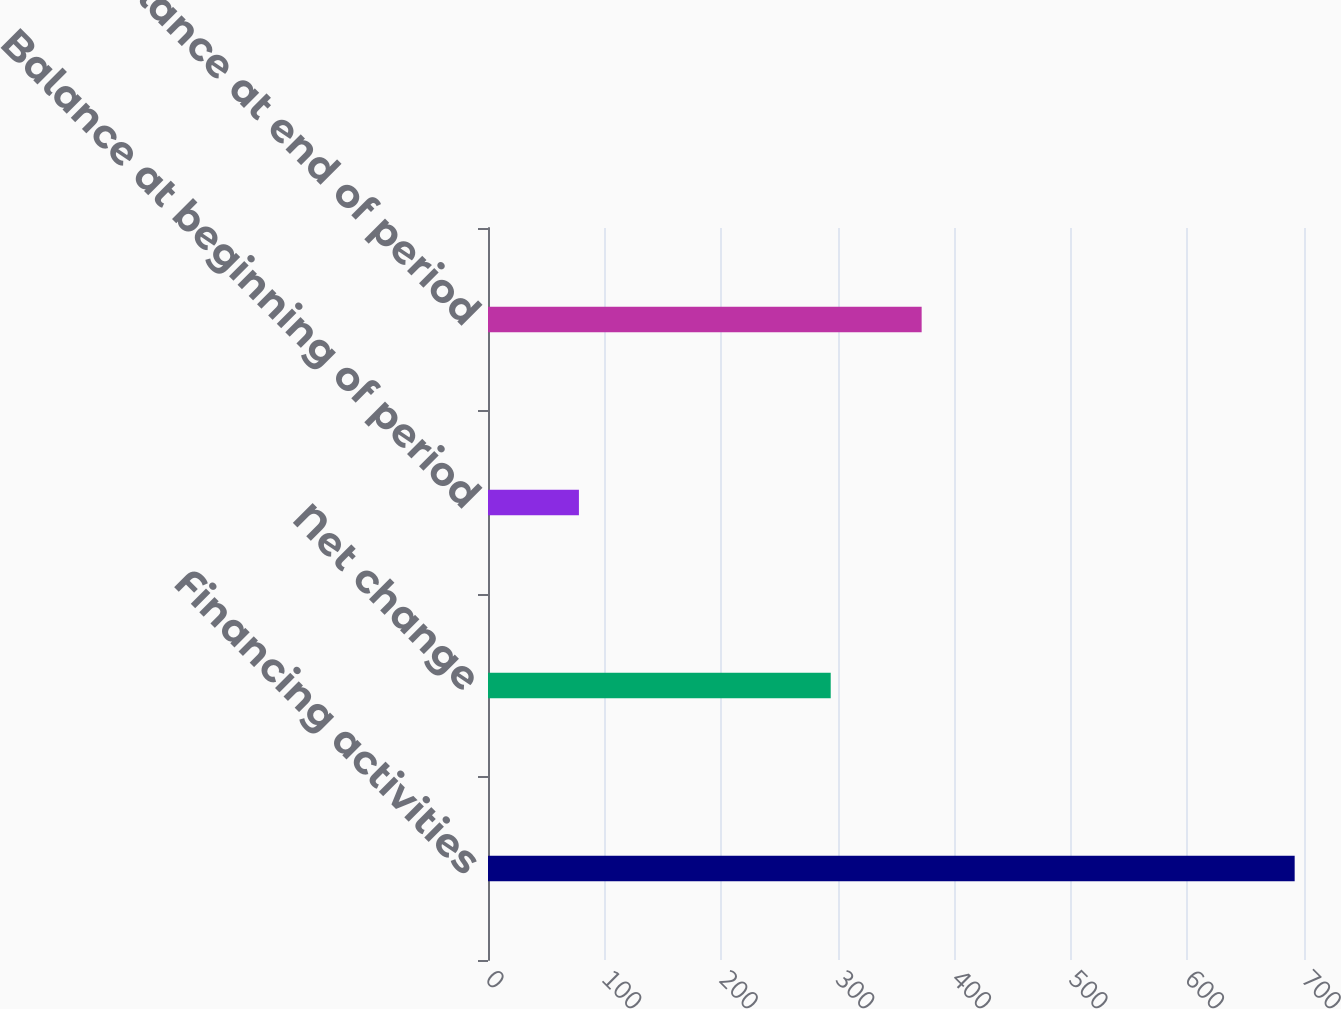Convert chart to OTSL. <chart><loc_0><loc_0><loc_500><loc_500><bar_chart><fcel>Financing activities<fcel>Net change<fcel>Balance at beginning of period<fcel>Balance at end of period<nl><fcel>692<fcel>294<fcel>78<fcel>372<nl></chart> 